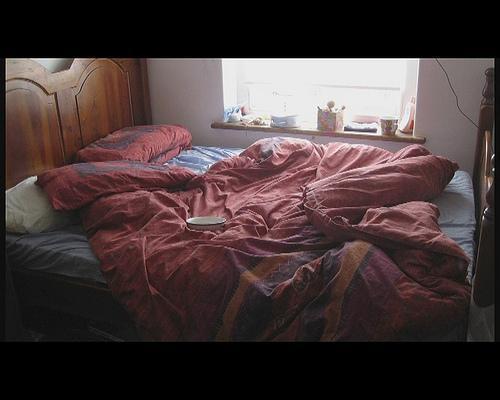How many bowls are there?
Give a very brief answer. 1. 